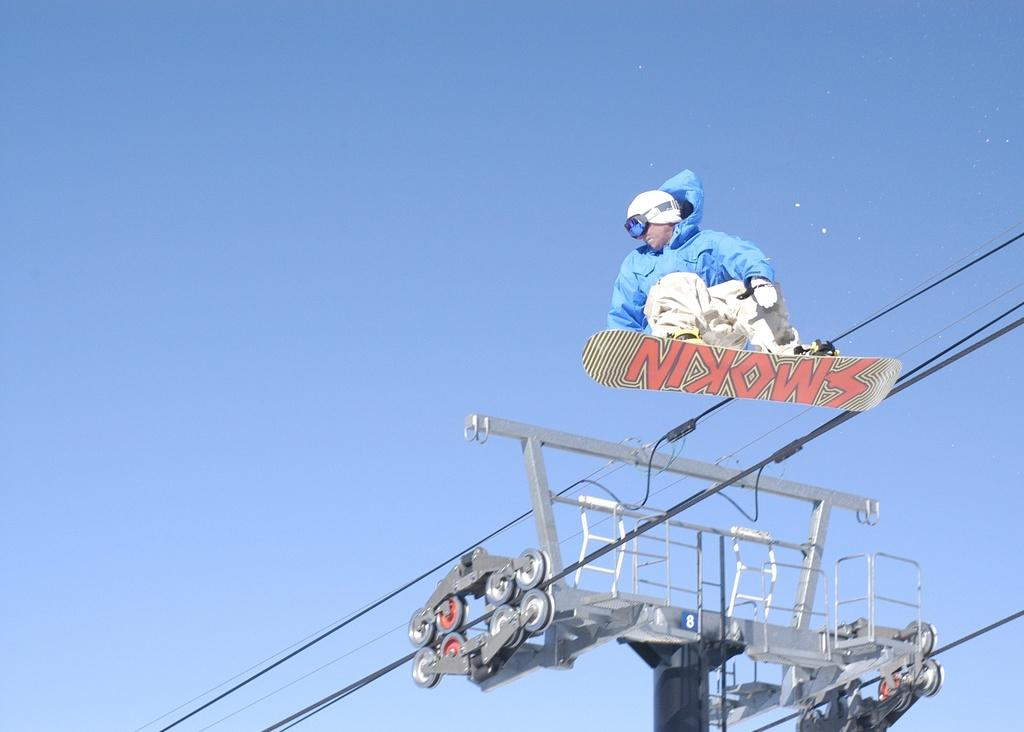What is the person in the image doing? The person is scattering the board in the image. What can be seen at the bottom of the image? There is a pole and wires at the bottom of the image. What is visible in the background of the image? The sky is visible in the background of the image. What is the color of the sky in the image? The color of the sky is blue. What type of event is happening in the image involving an umbrella? There is no event or umbrella present in the image. 